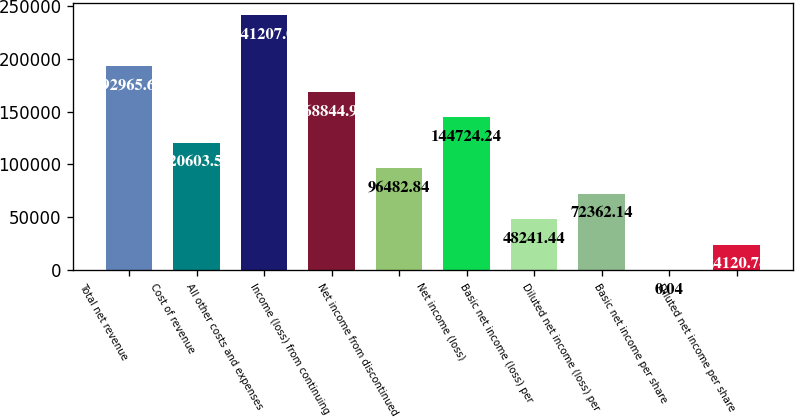<chart> <loc_0><loc_0><loc_500><loc_500><bar_chart><fcel>Total net revenue<fcel>Cost of revenue<fcel>All other costs and expenses<fcel>Income (loss) from continuing<fcel>Net income from discontinued<fcel>Net income (loss)<fcel>Basic net income (loss) per<fcel>Diluted net income (loss) per<fcel>Basic net income per share<fcel>Diluted net income per share<nl><fcel>192966<fcel>120604<fcel>241207<fcel>168845<fcel>96482.8<fcel>144724<fcel>48241.4<fcel>72362.1<fcel>0.04<fcel>24120.7<nl></chart> 